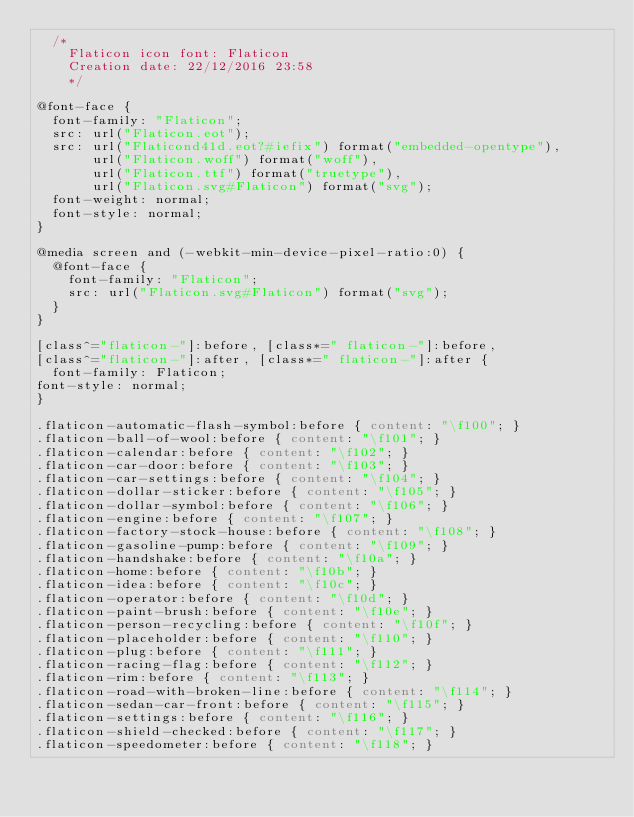<code> <loc_0><loc_0><loc_500><loc_500><_CSS_>	/*
  	Flaticon icon font: Flaticon
  	Creation date: 22/12/2016 23:58
  	*/

@font-face {
  font-family: "Flaticon";
  src: url("Flaticon.eot");
  src: url("Flaticond41d.eot?#iefix") format("embedded-opentype"),
       url("Flaticon.woff") format("woff"),
       url("Flaticon.ttf") format("truetype"),
       url("Flaticon.svg#Flaticon") format("svg");
  font-weight: normal;
  font-style: normal;
}

@media screen and (-webkit-min-device-pixel-ratio:0) {
  @font-face {
    font-family: "Flaticon";
    src: url("Flaticon.svg#Flaticon") format("svg");
  }
}

[class^="flaticon-"]:before, [class*=" flaticon-"]:before,
[class^="flaticon-"]:after, [class*=" flaticon-"]:after {   
  font-family: Flaticon;
font-style: normal;
}

.flaticon-automatic-flash-symbol:before { content: "\f100"; }
.flaticon-ball-of-wool:before { content: "\f101"; }
.flaticon-calendar:before { content: "\f102"; }
.flaticon-car-door:before { content: "\f103"; }
.flaticon-car-settings:before { content: "\f104"; }
.flaticon-dollar-sticker:before { content: "\f105"; }
.flaticon-dollar-symbol:before { content: "\f106"; }
.flaticon-engine:before { content: "\f107"; }
.flaticon-factory-stock-house:before { content: "\f108"; }
.flaticon-gasoline-pump:before { content: "\f109"; }
.flaticon-handshake:before { content: "\f10a"; }
.flaticon-home:before { content: "\f10b"; }
.flaticon-idea:before { content: "\f10c"; }
.flaticon-operator:before { content: "\f10d"; }
.flaticon-paint-brush:before { content: "\f10e"; }
.flaticon-person-recycling:before { content: "\f10f"; }
.flaticon-placeholder:before { content: "\f110"; }
.flaticon-plug:before { content: "\f111"; }
.flaticon-racing-flag:before { content: "\f112"; }
.flaticon-rim:before { content: "\f113"; }
.flaticon-road-with-broken-line:before { content: "\f114"; }
.flaticon-sedan-car-front:before { content: "\f115"; }
.flaticon-settings:before { content: "\f116"; }
.flaticon-shield-checked:before { content: "\f117"; }
.flaticon-speedometer:before { content: "\f118"; }</code> 